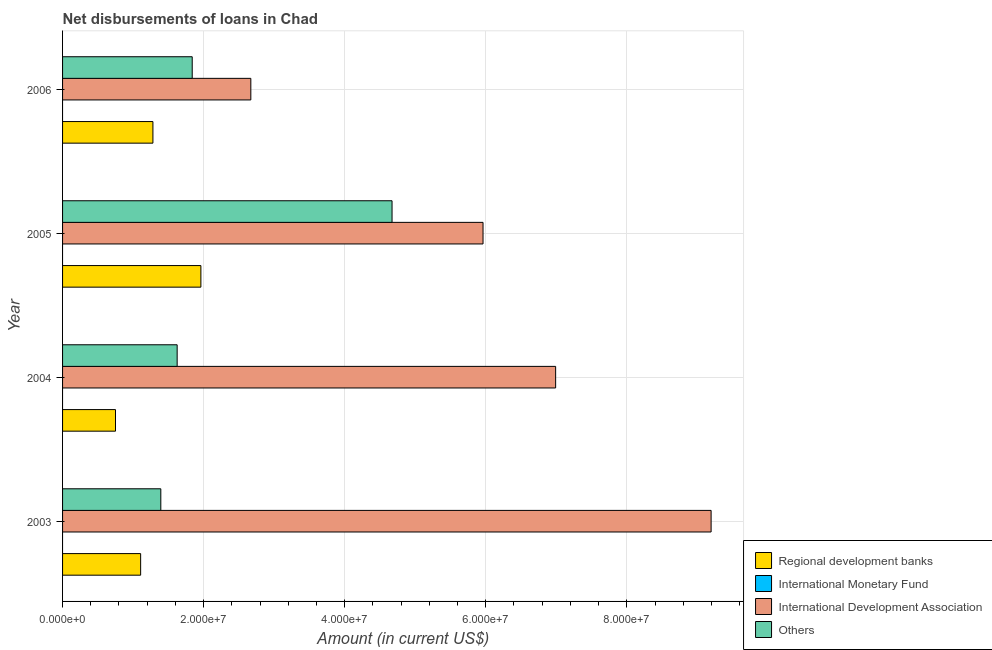Are the number of bars per tick equal to the number of legend labels?
Your response must be concise. No. How many bars are there on the 2nd tick from the top?
Make the answer very short. 3. How many bars are there on the 1st tick from the bottom?
Offer a terse response. 3. What is the label of the 4th group of bars from the top?
Your response must be concise. 2003. What is the amount of loan disimbursed by international monetary fund in 2004?
Ensure brevity in your answer.  0. Across all years, what is the maximum amount of loan disimbursed by regional development banks?
Make the answer very short. 1.96e+07. Across all years, what is the minimum amount of loan disimbursed by regional development banks?
Your answer should be very brief. 7.50e+06. In which year was the amount of loan disimbursed by other organisations maximum?
Keep it short and to the point. 2005. What is the total amount of loan disimbursed by other organisations in the graph?
Your answer should be very brief. 9.53e+07. What is the difference between the amount of loan disimbursed by international development association in 2004 and that in 2006?
Ensure brevity in your answer.  4.32e+07. What is the difference between the amount of loan disimbursed by international monetary fund in 2005 and the amount of loan disimbursed by regional development banks in 2006?
Your answer should be very brief. -1.28e+07. What is the average amount of loan disimbursed by international development association per year?
Give a very brief answer. 6.20e+07. In the year 2005, what is the difference between the amount of loan disimbursed by other organisations and amount of loan disimbursed by international development association?
Give a very brief answer. -1.29e+07. In how many years, is the amount of loan disimbursed by other organisations greater than 20000000 US$?
Your answer should be compact. 1. What is the ratio of the amount of loan disimbursed by other organisations in 2004 to that in 2005?
Make the answer very short. 0.35. Is the amount of loan disimbursed by international development association in 2004 less than that in 2006?
Your answer should be compact. No. Is the difference between the amount of loan disimbursed by regional development banks in 2003 and 2005 greater than the difference between the amount of loan disimbursed by other organisations in 2003 and 2005?
Your response must be concise. Yes. What is the difference between the highest and the second highest amount of loan disimbursed by other organisations?
Your response must be concise. 2.83e+07. What is the difference between the highest and the lowest amount of loan disimbursed by regional development banks?
Give a very brief answer. 1.21e+07. In how many years, is the amount of loan disimbursed by international monetary fund greater than the average amount of loan disimbursed by international monetary fund taken over all years?
Make the answer very short. 0. Is the sum of the amount of loan disimbursed by other organisations in 2004 and 2005 greater than the maximum amount of loan disimbursed by international monetary fund across all years?
Give a very brief answer. Yes. Is it the case that in every year, the sum of the amount of loan disimbursed by regional development banks and amount of loan disimbursed by international monetary fund is greater than the amount of loan disimbursed by international development association?
Provide a short and direct response. No. How many years are there in the graph?
Offer a very short reply. 4. What is the difference between two consecutive major ticks on the X-axis?
Offer a terse response. 2.00e+07. Does the graph contain grids?
Offer a terse response. Yes. How many legend labels are there?
Provide a succinct answer. 4. What is the title of the graph?
Make the answer very short. Net disbursements of loans in Chad. Does "Grants and Revenue" appear as one of the legend labels in the graph?
Make the answer very short. No. What is the label or title of the X-axis?
Keep it short and to the point. Amount (in current US$). What is the label or title of the Y-axis?
Offer a terse response. Year. What is the Amount (in current US$) in Regional development banks in 2003?
Your answer should be very brief. 1.11e+07. What is the Amount (in current US$) of International Monetary Fund in 2003?
Provide a short and direct response. 0. What is the Amount (in current US$) of International Development Association in 2003?
Give a very brief answer. 9.20e+07. What is the Amount (in current US$) of Others in 2003?
Ensure brevity in your answer.  1.39e+07. What is the Amount (in current US$) of Regional development banks in 2004?
Ensure brevity in your answer.  7.50e+06. What is the Amount (in current US$) of International Monetary Fund in 2004?
Provide a succinct answer. 0. What is the Amount (in current US$) of International Development Association in 2004?
Provide a short and direct response. 6.99e+07. What is the Amount (in current US$) of Others in 2004?
Your response must be concise. 1.62e+07. What is the Amount (in current US$) of Regional development banks in 2005?
Your response must be concise. 1.96e+07. What is the Amount (in current US$) in International Development Association in 2005?
Your answer should be compact. 5.96e+07. What is the Amount (in current US$) in Others in 2005?
Make the answer very short. 4.67e+07. What is the Amount (in current US$) of Regional development banks in 2006?
Provide a succinct answer. 1.28e+07. What is the Amount (in current US$) of International Monetary Fund in 2006?
Provide a succinct answer. 0. What is the Amount (in current US$) in International Development Association in 2006?
Offer a terse response. 2.67e+07. What is the Amount (in current US$) in Others in 2006?
Give a very brief answer. 1.84e+07. Across all years, what is the maximum Amount (in current US$) of Regional development banks?
Keep it short and to the point. 1.96e+07. Across all years, what is the maximum Amount (in current US$) in International Development Association?
Your answer should be compact. 9.20e+07. Across all years, what is the maximum Amount (in current US$) of Others?
Your answer should be very brief. 4.67e+07. Across all years, what is the minimum Amount (in current US$) of Regional development banks?
Your answer should be compact. 7.50e+06. Across all years, what is the minimum Amount (in current US$) in International Development Association?
Your answer should be very brief. 2.67e+07. Across all years, what is the minimum Amount (in current US$) in Others?
Your answer should be very brief. 1.39e+07. What is the total Amount (in current US$) of Regional development banks in the graph?
Offer a terse response. 5.10e+07. What is the total Amount (in current US$) in International Development Association in the graph?
Your answer should be compact. 2.48e+08. What is the total Amount (in current US$) in Others in the graph?
Your response must be concise. 9.53e+07. What is the difference between the Amount (in current US$) in Regional development banks in 2003 and that in 2004?
Ensure brevity in your answer.  3.57e+06. What is the difference between the Amount (in current US$) in International Development Association in 2003 and that in 2004?
Provide a succinct answer. 2.20e+07. What is the difference between the Amount (in current US$) in Others in 2003 and that in 2004?
Give a very brief answer. -2.32e+06. What is the difference between the Amount (in current US$) of Regional development banks in 2003 and that in 2005?
Your response must be concise. -8.54e+06. What is the difference between the Amount (in current US$) of International Development Association in 2003 and that in 2005?
Keep it short and to the point. 3.23e+07. What is the difference between the Amount (in current US$) in Others in 2003 and that in 2005?
Offer a very short reply. -3.28e+07. What is the difference between the Amount (in current US$) in Regional development banks in 2003 and that in 2006?
Provide a short and direct response. -1.74e+06. What is the difference between the Amount (in current US$) of International Development Association in 2003 and that in 2006?
Offer a very short reply. 6.53e+07. What is the difference between the Amount (in current US$) of Others in 2003 and that in 2006?
Your answer should be very brief. -4.45e+06. What is the difference between the Amount (in current US$) in Regional development banks in 2004 and that in 2005?
Provide a succinct answer. -1.21e+07. What is the difference between the Amount (in current US$) in International Development Association in 2004 and that in 2005?
Your answer should be compact. 1.03e+07. What is the difference between the Amount (in current US$) in Others in 2004 and that in 2005?
Provide a succinct answer. -3.05e+07. What is the difference between the Amount (in current US$) of Regional development banks in 2004 and that in 2006?
Provide a succinct answer. -5.31e+06. What is the difference between the Amount (in current US$) in International Development Association in 2004 and that in 2006?
Your response must be concise. 4.32e+07. What is the difference between the Amount (in current US$) of Others in 2004 and that in 2006?
Give a very brief answer. -2.14e+06. What is the difference between the Amount (in current US$) of Regional development banks in 2005 and that in 2006?
Offer a very short reply. 6.80e+06. What is the difference between the Amount (in current US$) of International Development Association in 2005 and that in 2006?
Provide a short and direct response. 3.29e+07. What is the difference between the Amount (in current US$) in Others in 2005 and that in 2006?
Provide a succinct answer. 2.83e+07. What is the difference between the Amount (in current US$) in Regional development banks in 2003 and the Amount (in current US$) in International Development Association in 2004?
Ensure brevity in your answer.  -5.88e+07. What is the difference between the Amount (in current US$) of Regional development banks in 2003 and the Amount (in current US$) of Others in 2004?
Keep it short and to the point. -5.18e+06. What is the difference between the Amount (in current US$) in International Development Association in 2003 and the Amount (in current US$) in Others in 2004?
Make the answer very short. 7.57e+07. What is the difference between the Amount (in current US$) in Regional development banks in 2003 and the Amount (in current US$) in International Development Association in 2005?
Your response must be concise. -4.85e+07. What is the difference between the Amount (in current US$) in Regional development banks in 2003 and the Amount (in current US$) in Others in 2005?
Provide a short and direct response. -3.56e+07. What is the difference between the Amount (in current US$) in International Development Association in 2003 and the Amount (in current US$) in Others in 2005?
Make the answer very short. 4.52e+07. What is the difference between the Amount (in current US$) of Regional development banks in 2003 and the Amount (in current US$) of International Development Association in 2006?
Your response must be concise. -1.56e+07. What is the difference between the Amount (in current US$) in Regional development banks in 2003 and the Amount (in current US$) in Others in 2006?
Provide a short and direct response. -7.31e+06. What is the difference between the Amount (in current US$) of International Development Association in 2003 and the Amount (in current US$) of Others in 2006?
Offer a terse response. 7.36e+07. What is the difference between the Amount (in current US$) in Regional development banks in 2004 and the Amount (in current US$) in International Development Association in 2005?
Your answer should be compact. -5.21e+07. What is the difference between the Amount (in current US$) of Regional development banks in 2004 and the Amount (in current US$) of Others in 2005?
Make the answer very short. -3.92e+07. What is the difference between the Amount (in current US$) in International Development Association in 2004 and the Amount (in current US$) in Others in 2005?
Your answer should be compact. 2.32e+07. What is the difference between the Amount (in current US$) of Regional development banks in 2004 and the Amount (in current US$) of International Development Association in 2006?
Give a very brief answer. -1.92e+07. What is the difference between the Amount (in current US$) in Regional development banks in 2004 and the Amount (in current US$) in Others in 2006?
Give a very brief answer. -1.09e+07. What is the difference between the Amount (in current US$) of International Development Association in 2004 and the Amount (in current US$) of Others in 2006?
Your answer should be very brief. 5.15e+07. What is the difference between the Amount (in current US$) in Regional development banks in 2005 and the Amount (in current US$) in International Development Association in 2006?
Offer a terse response. -7.08e+06. What is the difference between the Amount (in current US$) in Regional development banks in 2005 and the Amount (in current US$) in Others in 2006?
Give a very brief answer. 1.23e+06. What is the difference between the Amount (in current US$) of International Development Association in 2005 and the Amount (in current US$) of Others in 2006?
Your response must be concise. 4.12e+07. What is the average Amount (in current US$) in Regional development banks per year?
Provide a short and direct response. 1.27e+07. What is the average Amount (in current US$) of International Development Association per year?
Give a very brief answer. 6.20e+07. What is the average Amount (in current US$) in Others per year?
Provide a short and direct response. 2.38e+07. In the year 2003, what is the difference between the Amount (in current US$) of Regional development banks and Amount (in current US$) of International Development Association?
Your answer should be compact. -8.09e+07. In the year 2003, what is the difference between the Amount (in current US$) of Regional development banks and Amount (in current US$) of Others?
Provide a succinct answer. -2.86e+06. In the year 2003, what is the difference between the Amount (in current US$) of International Development Association and Amount (in current US$) of Others?
Ensure brevity in your answer.  7.80e+07. In the year 2004, what is the difference between the Amount (in current US$) in Regional development banks and Amount (in current US$) in International Development Association?
Give a very brief answer. -6.24e+07. In the year 2004, what is the difference between the Amount (in current US$) of Regional development banks and Amount (in current US$) of Others?
Keep it short and to the point. -8.74e+06. In the year 2004, what is the difference between the Amount (in current US$) of International Development Association and Amount (in current US$) of Others?
Ensure brevity in your answer.  5.37e+07. In the year 2005, what is the difference between the Amount (in current US$) in Regional development banks and Amount (in current US$) in International Development Association?
Keep it short and to the point. -4.00e+07. In the year 2005, what is the difference between the Amount (in current US$) of Regional development banks and Amount (in current US$) of Others?
Provide a succinct answer. -2.71e+07. In the year 2005, what is the difference between the Amount (in current US$) of International Development Association and Amount (in current US$) of Others?
Ensure brevity in your answer.  1.29e+07. In the year 2006, what is the difference between the Amount (in current US$) of Regional development banks and Amount (in current US$) of International Development Association?
Make the answer very short. -1.39e+07. In the year 2006, what is the difference between the Amount (in current US$) of Regional development banks and Amount (in current US$) of Others?
Ensure brevity in your answer.  -5.57e+06. In the year 2006, what is the difference between the Amount (in current US$) in International Development Association and Amount (in current US$) in Others?
Keep it short and to the point. 8.31e+06. What is the ratio of the Amount (in current US$) of Regional development banks in 2003 to that in 2004?
Offer a very short reply. 1.48. What is the ratio of the Amount (in current US$) in International Development Association in 2003 to that in 2004?
Provide a succinct answer. 1.32. What is the ratio of the Amount (in current US$) of Others in 2003 to that in 2004?
Provide a short and direct response. 0.86. What is the ratio of the Amount (in current US$) of Regional development banks in 2003 to that in 2005?
Your response must be concise. 0.56. What is the ratio of the Amount (in current US$) in International Development Association in 2003 to that in 2005?
Your response must be concise. 1.54. What is the ratio of the Amount (in current US$) of Others in 2003 to that in 2005?
Offer a terse response. 0.3. What is the ratio of the Amount (in current US$) in Regional development banks in 2003 to that in 2006?
Your response must be concise. 0.86. What is the ratio of the Amount (in current US$) of International Development Association in 2003 to that in 2006?
Your answer should be very brief. 3.44. What is the ratio of the Amount (in current US$) in Others in 2003 to that in 2006?
Offer a terse response. 0.76. What is the ratio of the Amount (in current US$) in Regional development banks in 2004 to that in 2005?
Provide a succinct answer. 0.38. What is the ratio of the Amount (in current US$) in International Development Association in 2004 to that in 2005?
Make the answer very short. 1.17. What is the ratio of the Amount (in current US$) in Others in 2004 to that in 2005?
Your response must be concise. 0.35. What is the ratio of the Amount (in current US$) of Regional development banks in 2004 to that in 2006?
Your answer should be compact. 0.59. What is the ratio of the Amount (in current US$) in International Development Association in 2004 to that in 2006?
Ensure brevity in your answer.  2.62. What is the ratio of the Amount (in current US$) of Others in 2004 to that in 2006?
Make the answer very short. 0.88. What is the ratio of the Amount (in current US$) of Regional development banks in 2005 to that in 2006?
Provide a succinct answer. 1.53. What is the ratio of the Amount (in current US$) in International Development Association in 2005 to that in 2006?
Offer a very short reply. 2.23. What is the ratio of the Amount (in current US$) in Others in 2005 to that in 2006?
Your response must be concise. 2.54. What is the difference between the highest and the second highest Amount (in current US$) of Regional development banks?
Keep it short and to the point. 6.80e+06. What is the difference between the highest and the second highest Amount (in current US$) in International Development Association?
Keep it short and to the point. 2.20e+07. What is the difference between the highest and the second highest Amount (in current US$) of Others?
Provide a succinct answer. 2.83e+07. What is the difference between the highest and the lowest Amount (in current US$) in Regional development banks?
Keep it short and to the point. 1.21e+07. What is the difference between the highest and the lowest Amount (in current US$) of International Development Association?
Your response must be concise. 6.53e+07. What is the difference between the highest and the lowest Amount (in current US$) of Others?
Provide a succinct answer. 3.28e+07. 